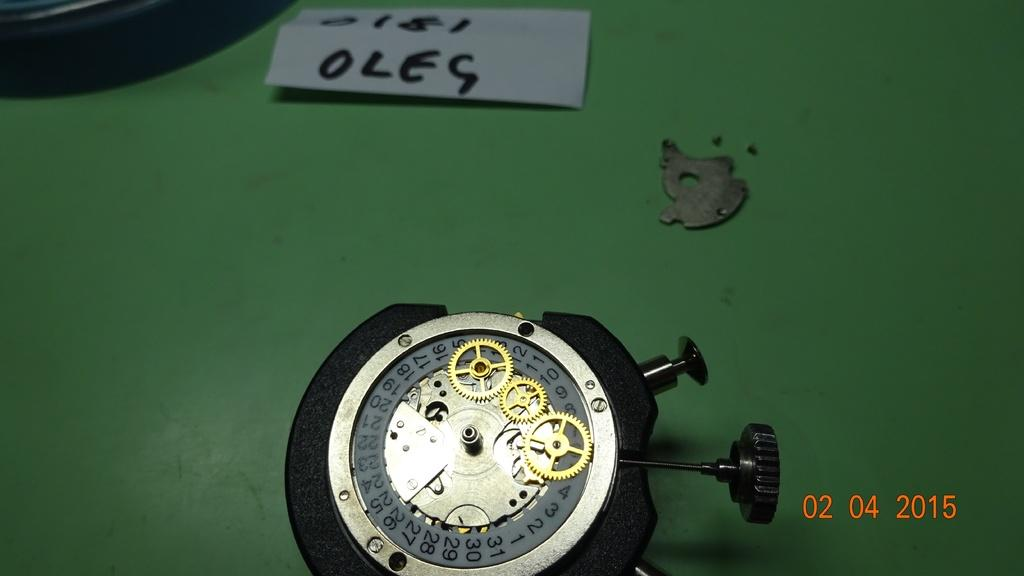<image>
Relay a brief, clear account of the picture shown. A broken watch with a piece of paper near it that says "OLEG". 